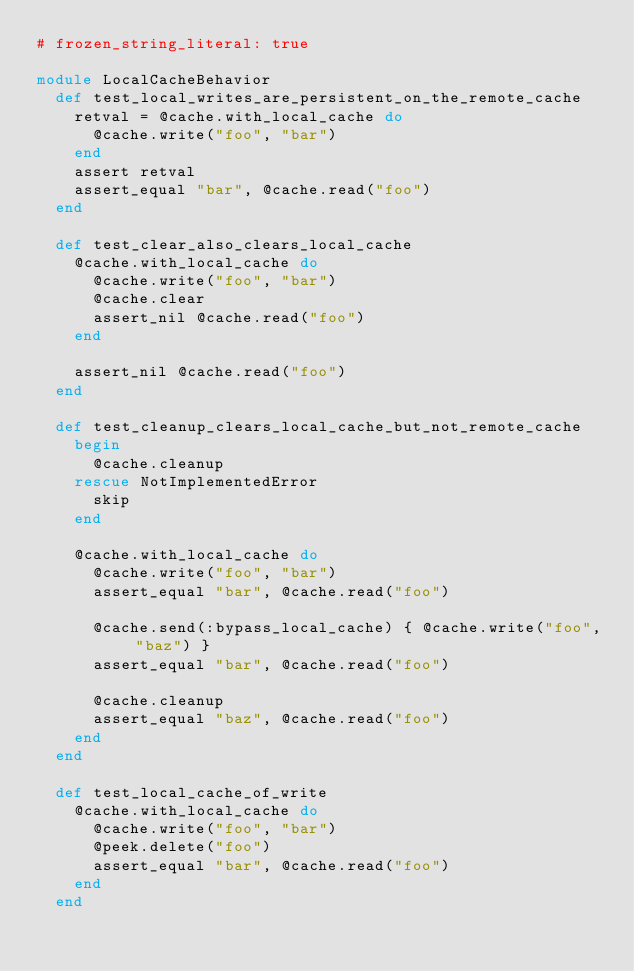<code> <loc_0><loc_0><loc_500><loc_500><_Ruby_># frozen_string_literal: true

module LocalCacheBehavior
  def test_local_writes_are_persistent_on_the_remote_cache
    retval = @cache.with_local_cache do
      @cache.write("foo", "bar")
    end
    assert retval
    assert_equal "bar", @cache.read("foo")
  end

  def test_clear_also_clears_local_cache
    @cache.with_local_cache do
      @cache.write("foo", "bar")
      @cache.clear
      assert_nil @cache.read("foo")
    end

    assert_nil @cache.read("foo")
  end

  def test_cleanup_clears_local_cache_but_not_remote_cache
    begin
      @cache.cleanup
    rescue NotImplementedError
      skip
    end

    @cache.with_local_cache do
      @cache.write("foo", "bar")
      assert_equal "bar", @cache.read("foo")

      @cache.send(:bypass_local_cache) { @cache.write("foo", "baz") }
      assert_equal "bar", @cache.read("foo")

      @cache.cleanup
      assert_equal "baz", @cache.read("foo")
    end
  end

  def test_local_cache_of_write
    @cache.with_local_cache do
      @cache.write("foo", "bar")
      @peek.delete("foo")
      assert_equal "bar", @cache.read("foo")
    end
  end
</code> 